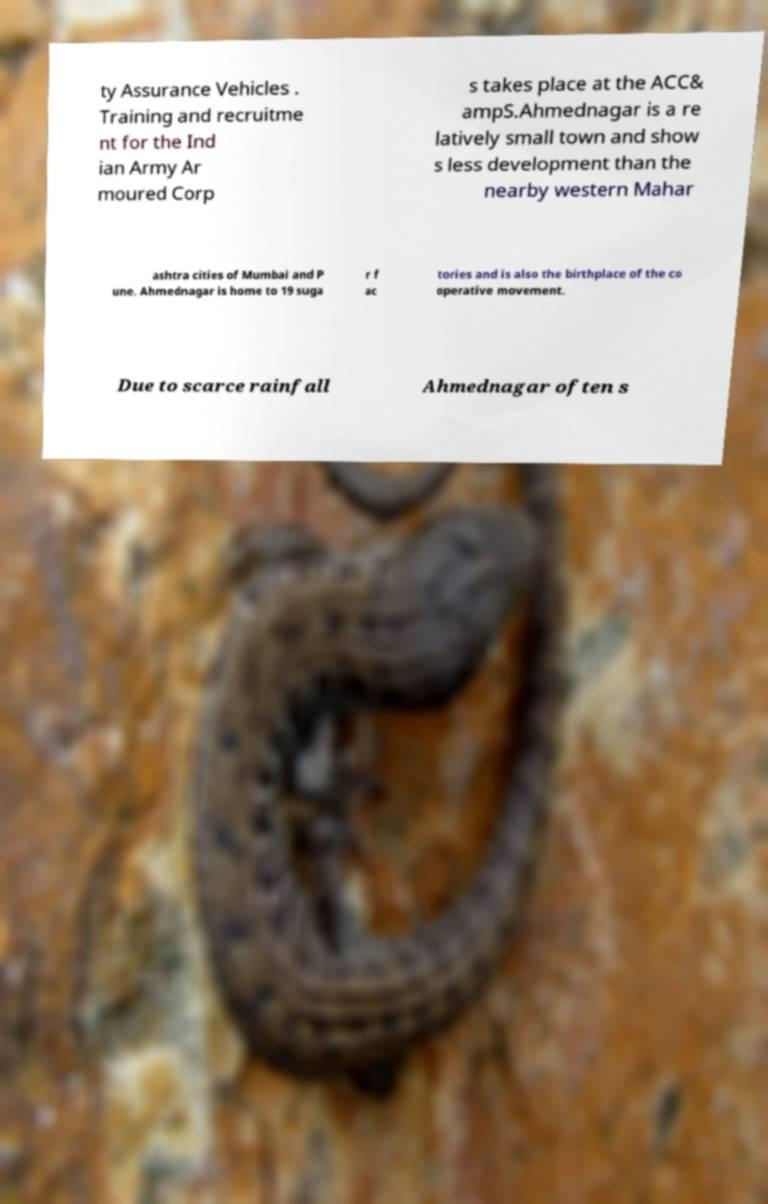What messages or text are displayed in this image? I need them in a readable, typed format. ty Assurance Vehicles . Training and recruitme nt for the Ind ian Army Ar moured Corp s takes place at the ACC& ampS.Ahmednagar is a re latively small town and show s less development than the nearby western Mahar ashtra cities of Mumbai and P une. Ahmednagar is home to 19 suga r f ac tories and is also the birthplace of the co operative movement. Due to scarce rainfall Ahmednagar often s 